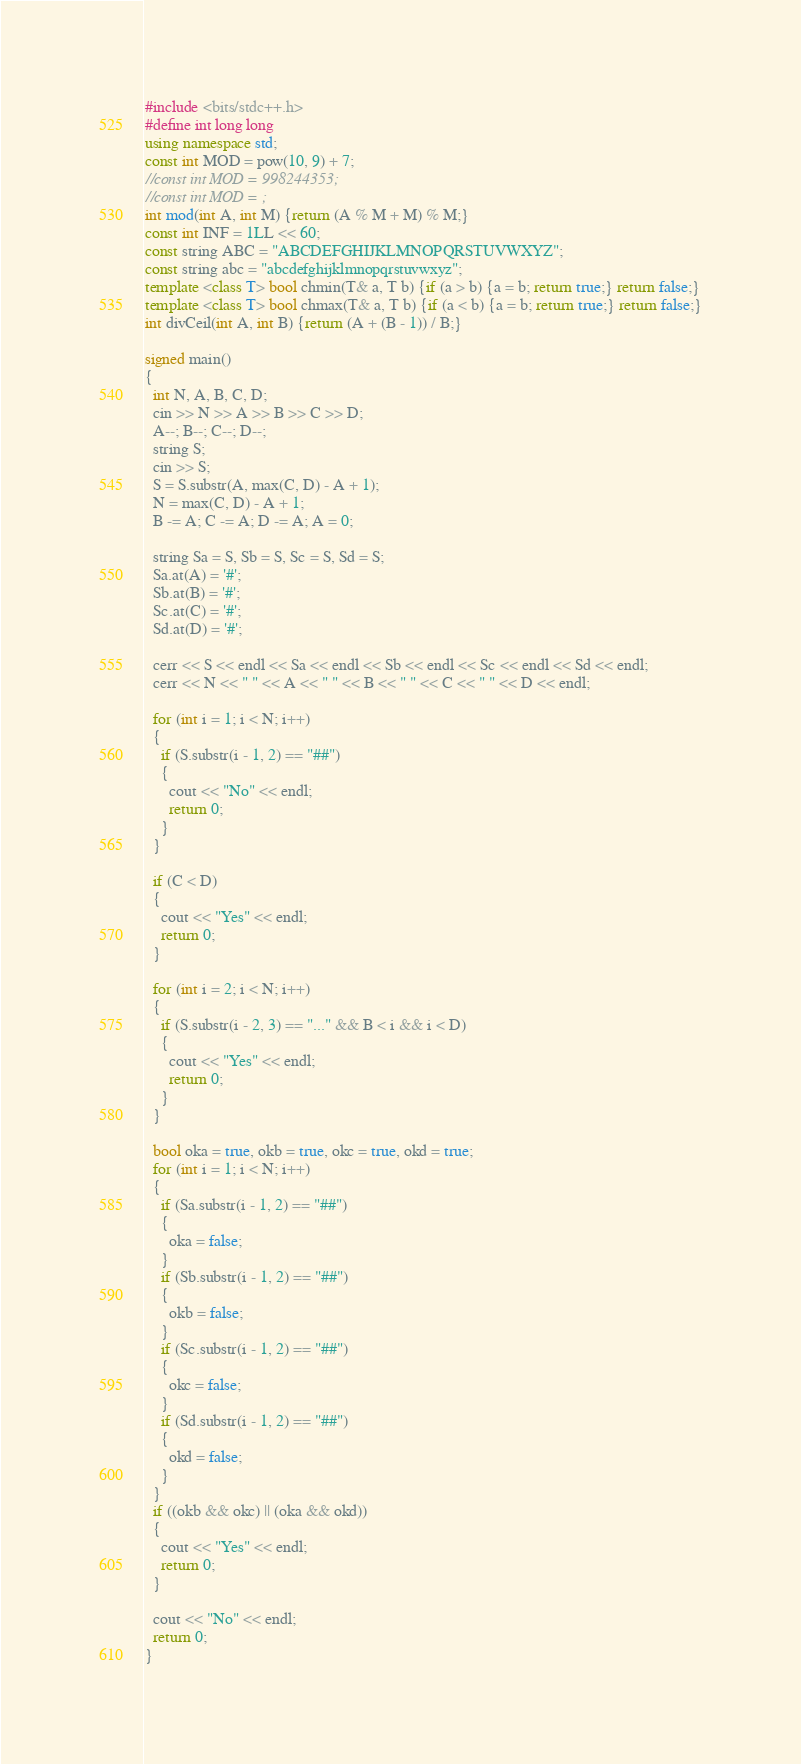Convert code to text. <code><loc_0><loc_0><loc_500><loc_500><_C++_>#include <bits/stdc++.h>
#define int long long
using namespace std;
const int MOD = pow(10, 9) + 7;
//const int MOD = 998244353;
//const int MOD = ;
int mod(int A, int M) {return (A % M + M) % M;}
const int INF = 1LL << 60;
const string ABC = "ABCDEFGHIJKLMNOPQRSTUVWXYZ";
const string abc = "abcdefghijklmnopqrstuvwxyz";
template <class T> bool chmin(T& a, T b) {if (a > b) {a = b; return true;} return false;}
template <class T> bool chmax(T& a, T b) {if (a < b) {a = b; return true;} return false;}
int divCeil(int A, int B) {return (A + (B - 1)) / B;}

signed main()
{
  int N, A, B, C, D;
  cin >> N >> A >> B >> C >> D;
  A--; B--; C--; D--;
  string S;
  cin >> S;
  S = S.substr(A, max(C, D) - A + 1);
  N = max(C, D) - A + 1;
  B -= A; C -= A; D -= A; A = 0;
  
  string Sa = S, Sb = S, Sc = S, Sd = S;
  Sa.at(A) = '#';
  Sb.at(B) = '#';
  Sc.at(C) = '#';
  Sd.at(D) = '#';
  
  cerr << S << endl << Sa << endl << Sb << endl << Sc << endl << Sd << endl;
  cerr << N << " " << A << " " << B << " " << C << " " << D << endl;
  
  for (int i = 1; i < N; i++)
  {
    if (S.substr(i - 1, 2) == "##")
    {
      cout << "No" << endl;
      return 0;
    }
  }

  if (C < D)
  {
    cout << "Yes" << endl;
    return 0;
  }

  for (int i = 2; i < N; i++)
  {
    if (S.substr(i - 2, 3) == "..." && B < i && i < D)
    {
      cout << "Yes" << endl;
      return 0;
    }
  }
  
  bool oka = true, okb = true, okc = true, okd = true;
  for (int i = 1; i < N; i++)
  {
    if (Sa.substr(i - 1, 2) == "##")
    {
      oka = false;
    }
    if (Sb.substr(i - 1, 2) == "##")
    {
      okb = false;
    }
    if (Sc.substr(i - 1, 2) == "##")
    {
      okc = false;
    }
    if (Sd.substr(i - 1, 2) == "##")
    {
      okd = false;
    }
  }
  if ((okb && okc) || (oka && okd))
  {
    cout << "Yes" << endl;
    return 0;
  }
  
  cout << "No" << endl;
  return 0;
}</code> 